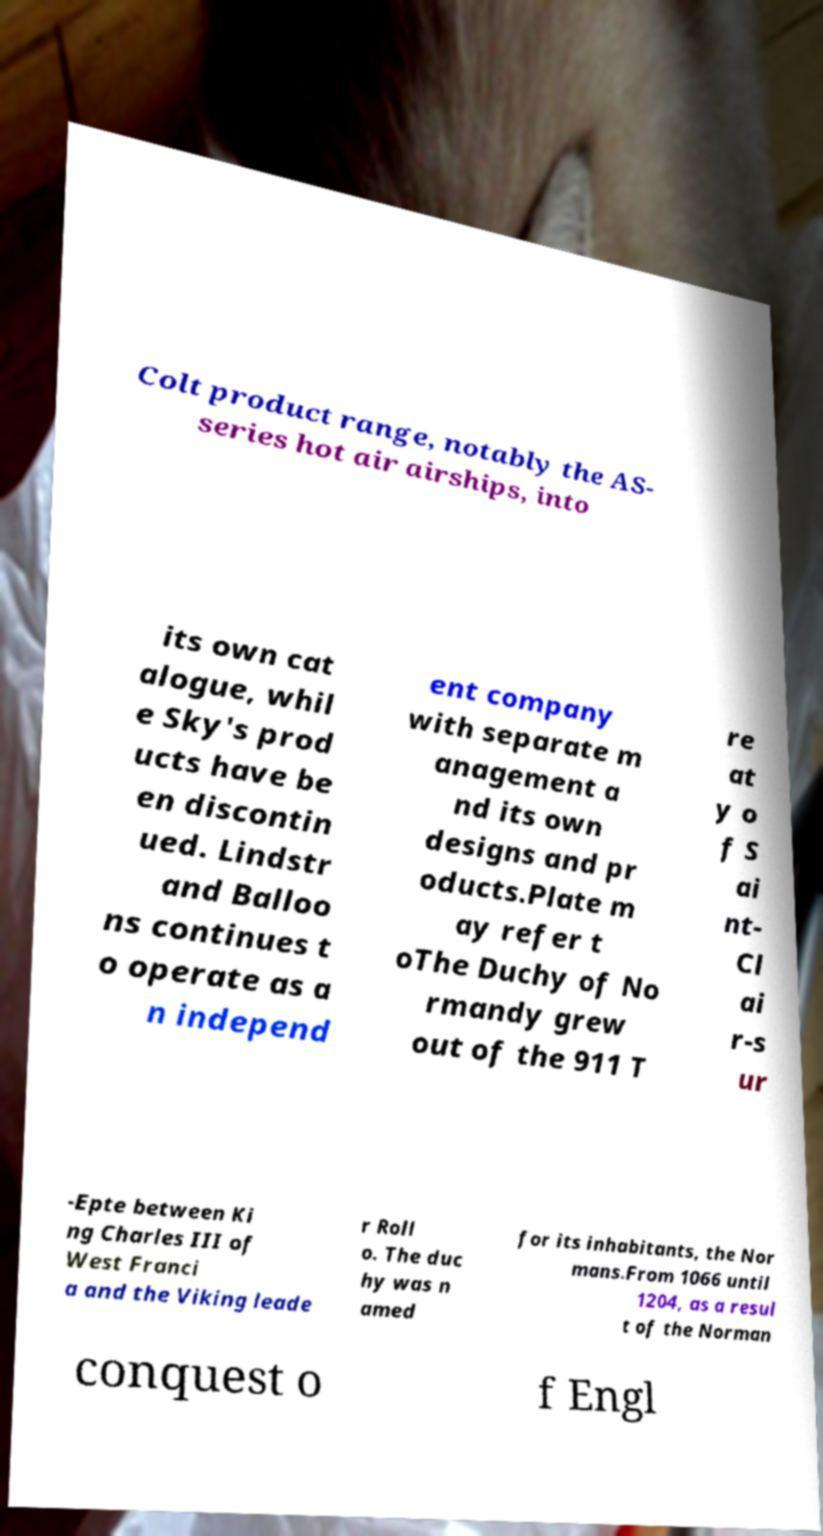Please identify and transcribe the text found in this image. Colt product range, notably the AS- series hot air airships, into its own cat alogue, whil e Sky's prod ucts have be en discontin ued. Lindstr and Balloo ns continues t o operate as a n independ ent company with separate m anagement a nd its own designs and pr oducts.Plate m ay refer t oThe Duchy of No rmandy grew out of the 911 T re at y o f S ai nt- Cl ai r-s ur -Epte between Ki ng Charles III of West Franci a and the Viking leade r Roll o. The duc hy was n amed for its inhabitants, the Nor mans.From 1066 until 1204, as a resul t of the Norman conquest o f Engl 